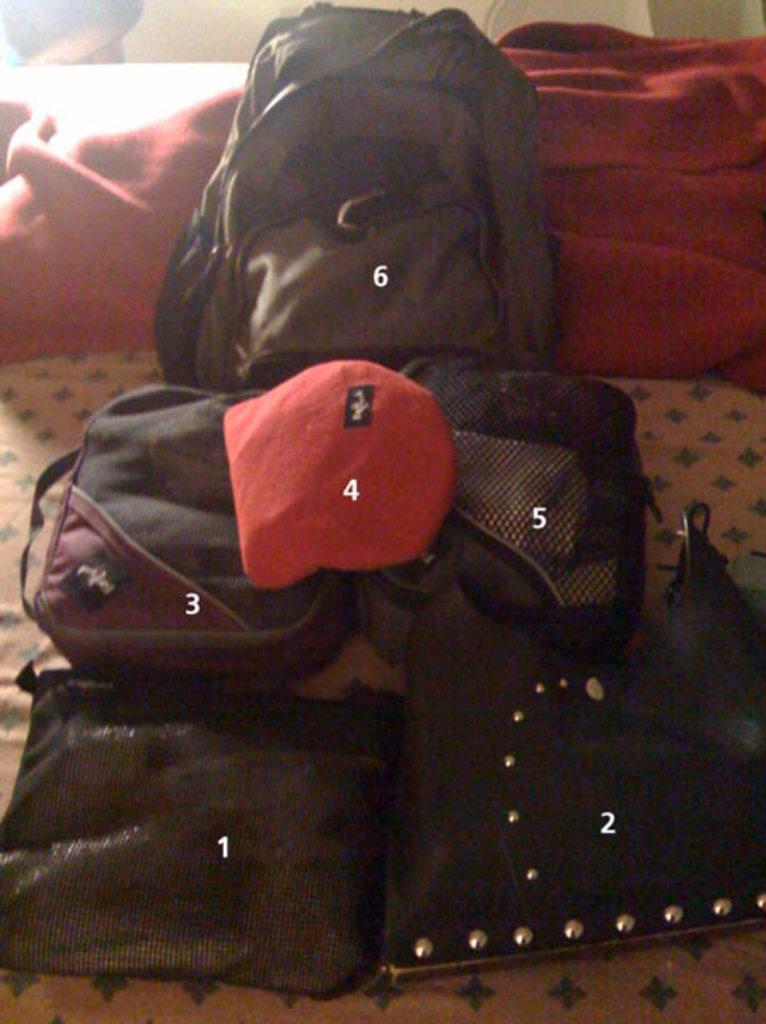Please provide a concise description of this image. In this image we can see six bags. For each bag numbering is given. 